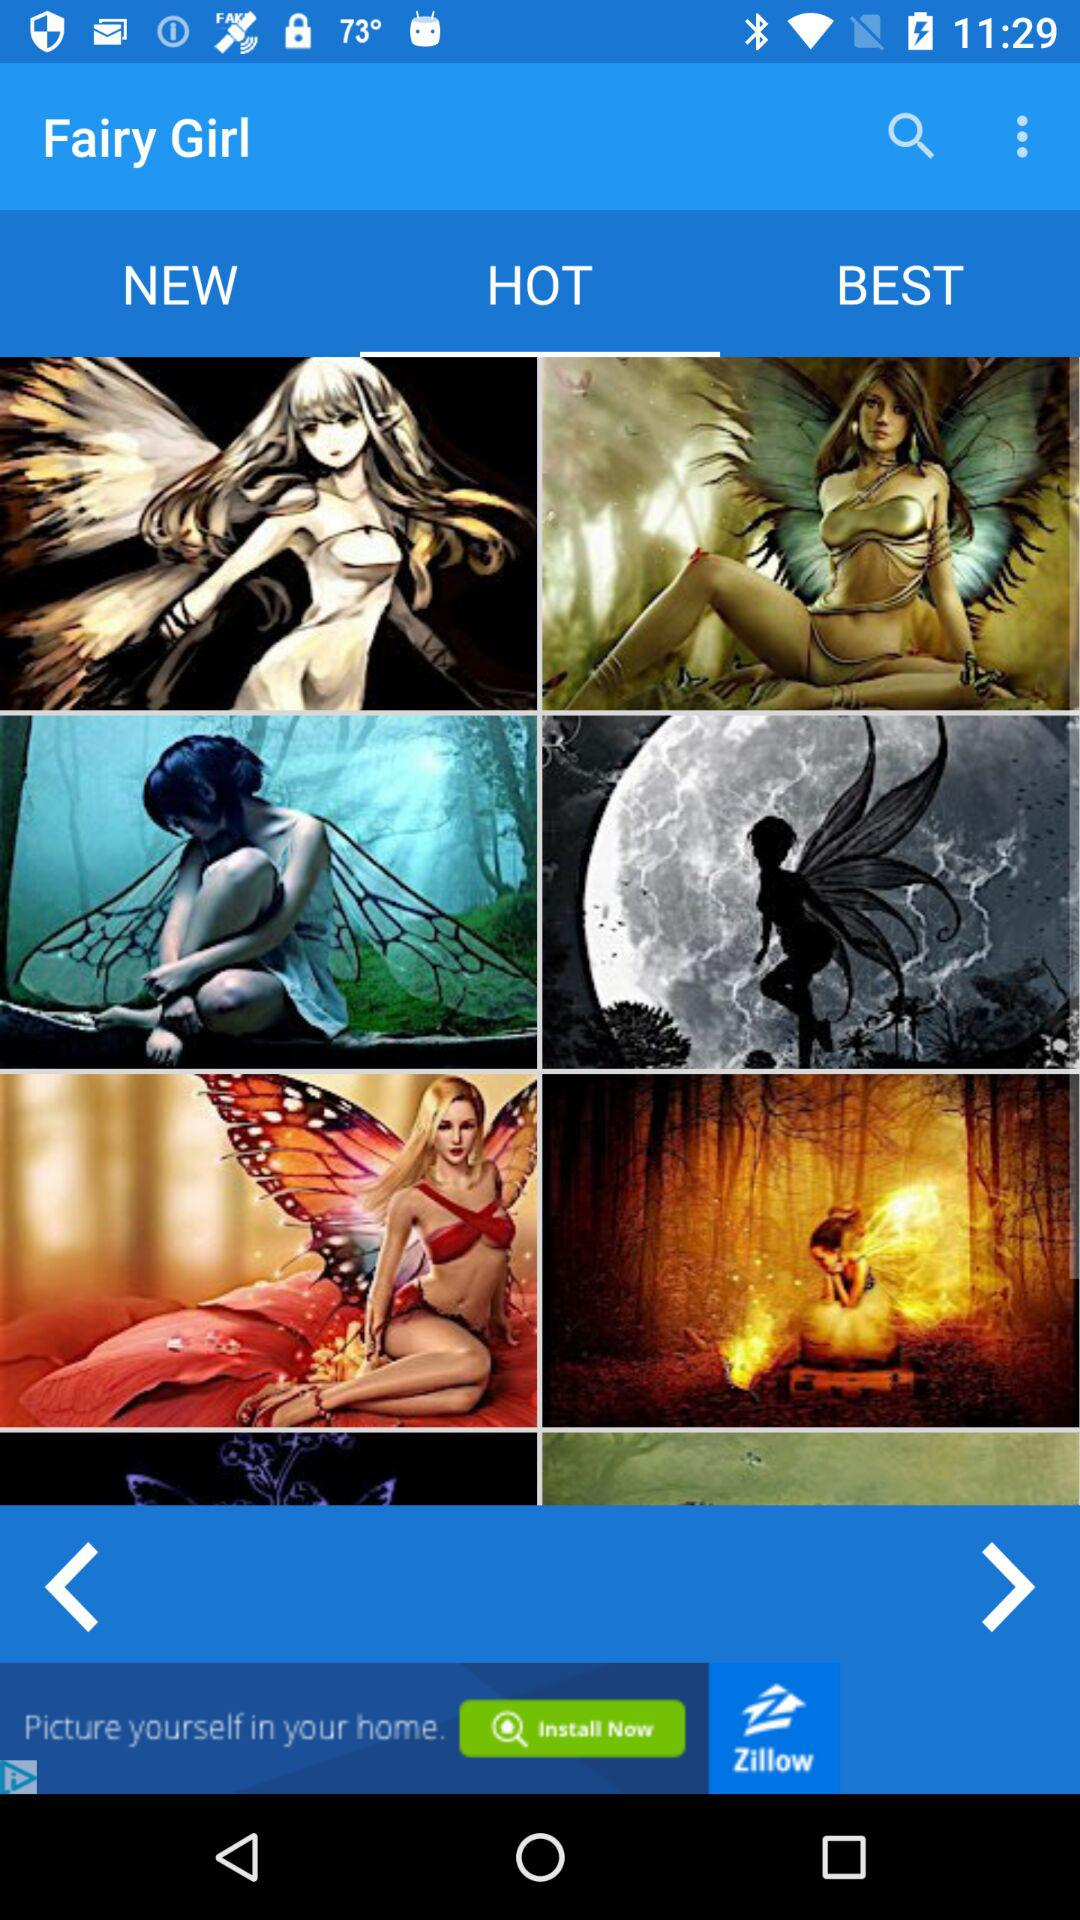Which tab is selected? The selected tab is "HOT". 